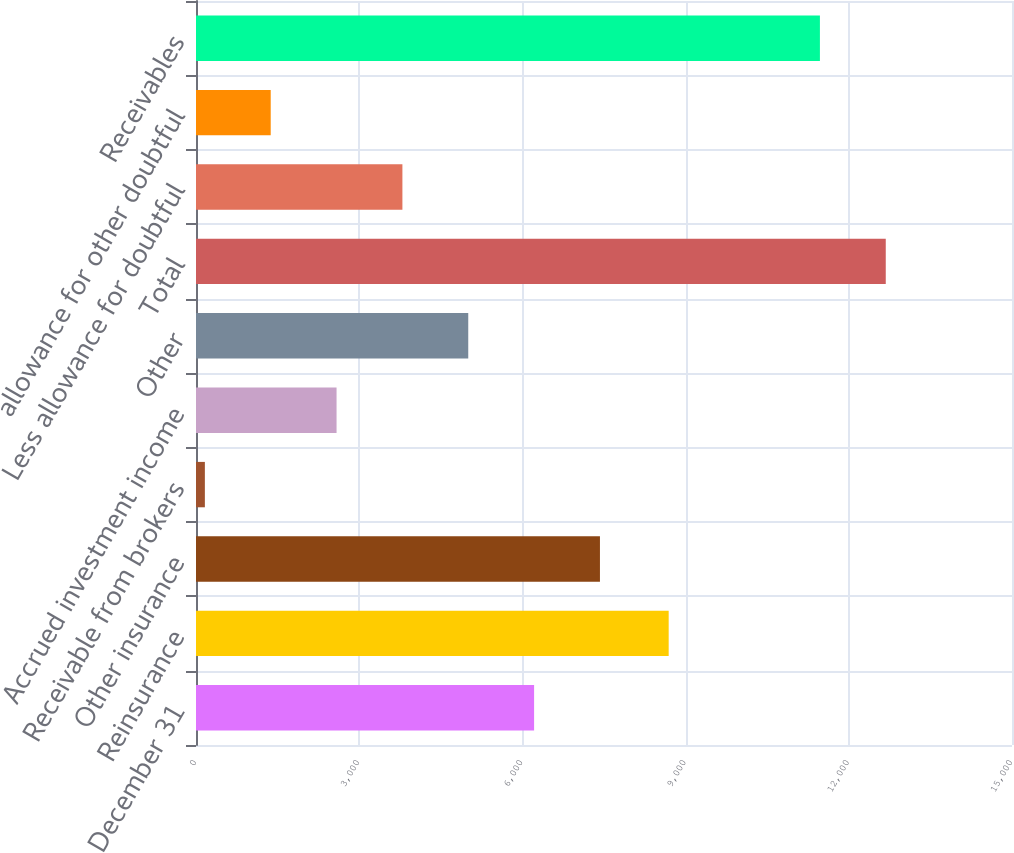Convert chart to OTSL. <chart><loc_0><loc_0><loc_500><loc_500><bar_chart><fcel>December 31<fcel>Reinsurance<fcel>Other insurance<fcel>Receivable from brokers<fcel>Accrued investment income<fcel>Other<fcel>Total<fcel>Less allowance for doubtful<fcel>allowance for other doubtful<fcel>Receivables<nl><fcel>6215<fcel>8689<fcel>7425.4<fcel>163<fcel>2583.8<fcel>5004.6<fcel>12679.4<fcel>3794.2<fcel>1373.4<fcel>11469<nl></chart> 